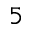Convert formula to latex. <formula><loc_0><loc_0><loc_500><loc_500>_ { 5 }</formula> 